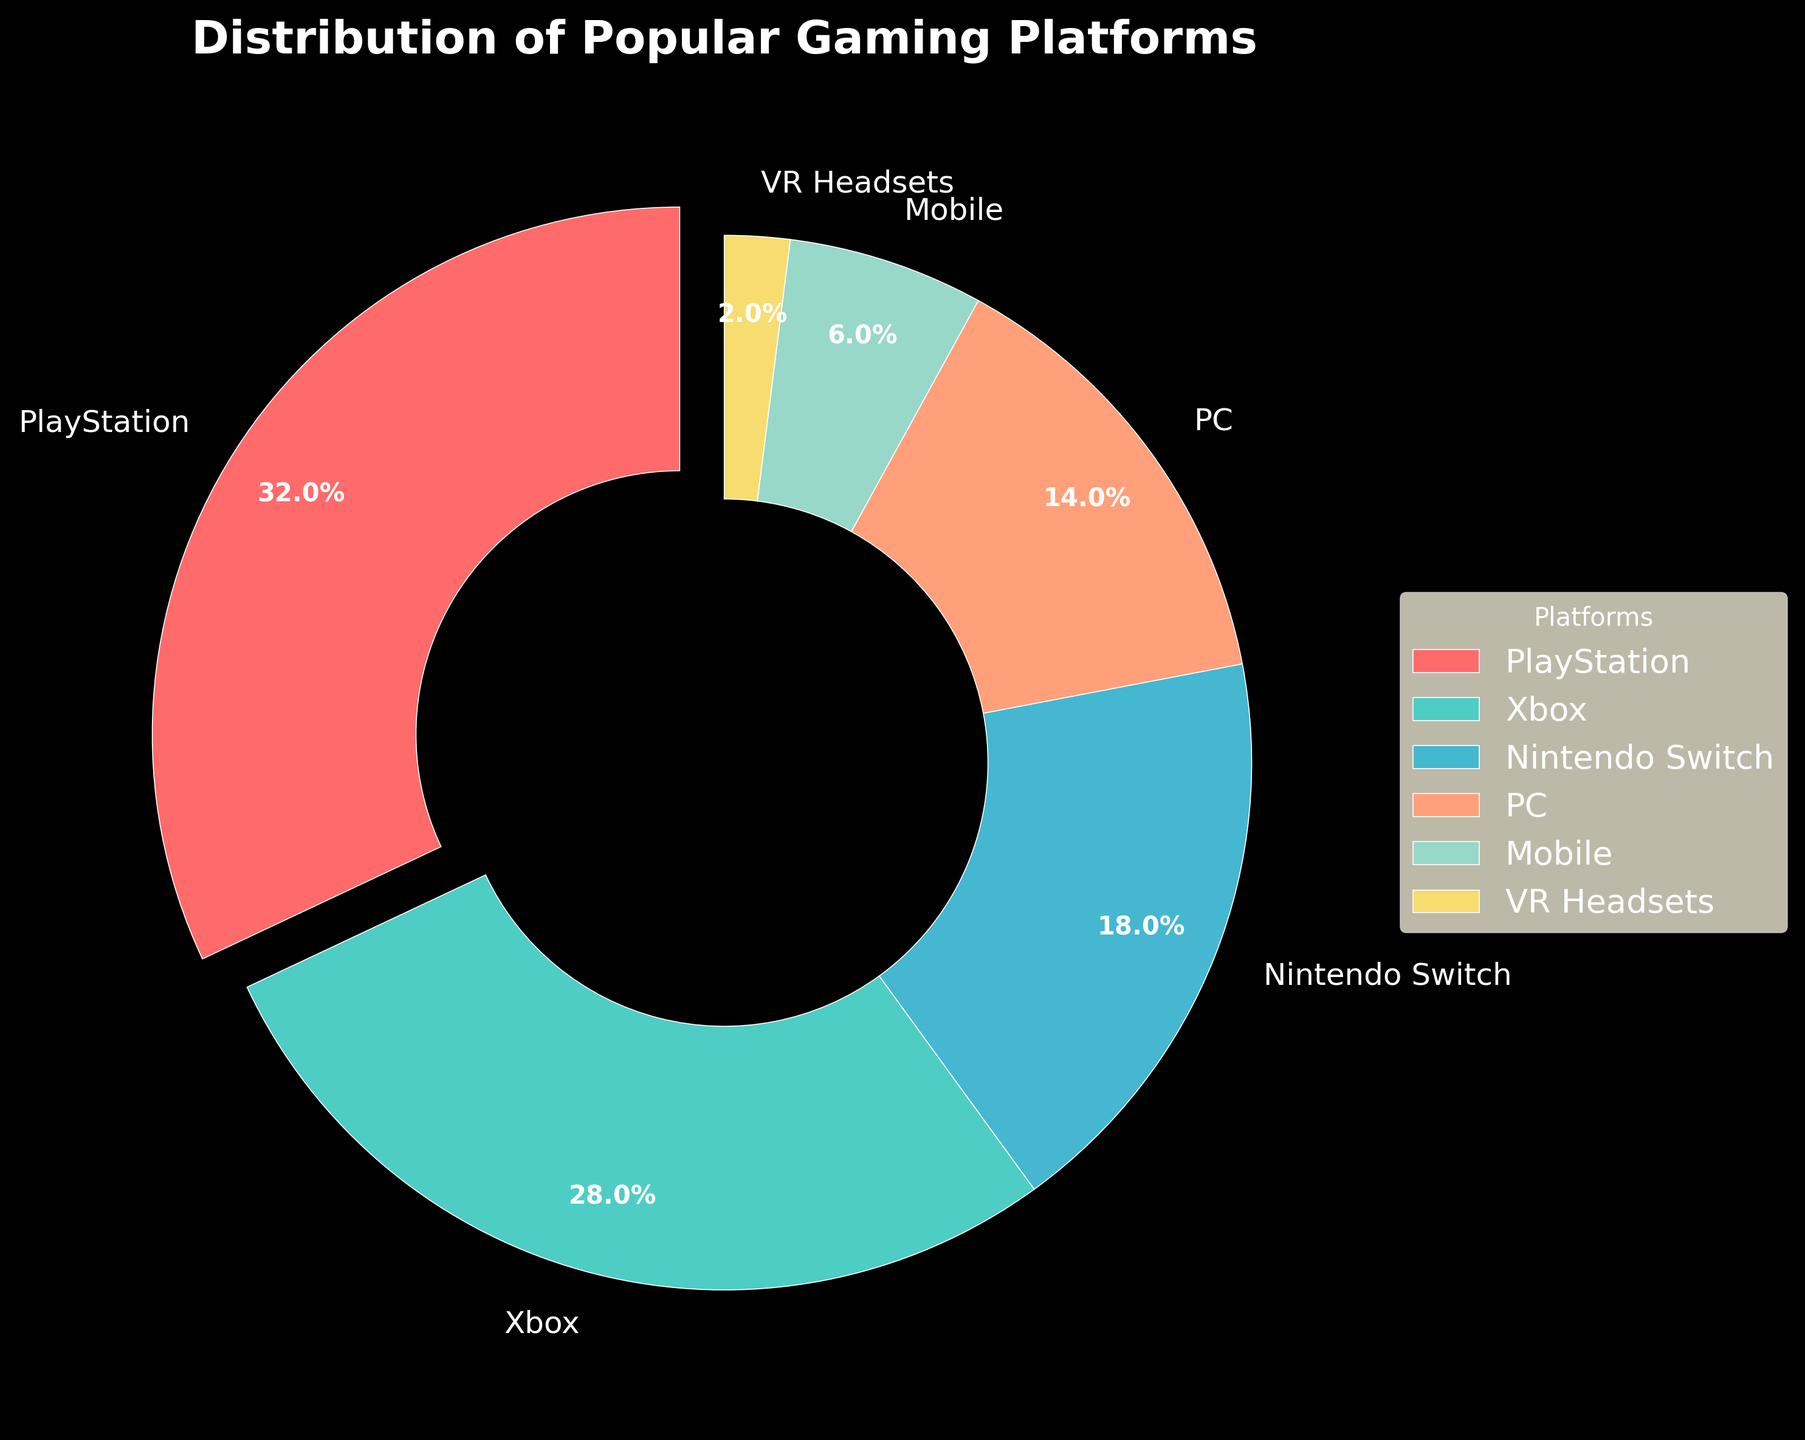Which gaming platform has the highest distribution among local consumers? The gaming platform with the highest distribution can be identified by the largest slice in the pie chart. From the chart, PlayStation has the largest slice with 32%.
Answer: PlayStation Which two platforms have the closest distribution percentages? To find the two platforms with the closest percentages, compare each slice in the pie chart. From the chart, Xbox and Nintendo Switch have distributions of 28% and 18%, respectively, making them the closest pair.
Answer: Xbox and Nintendo Switch What is the combined percentage of users who prefer PC and Mobile platforms? Add the percentages of the PC and Mobile platforms by summing the values from the chart. PC has 14% and Mobile has 6%, so the combined percentage is 14% + 6% = 20%.
Answer: 20% How much more popular is PlayStation compared to VR Headsets? Subtract the percentage of VR Headsets from the percentage of PlayStation. PlayStation has 32% and VR Headsets have 2%, so the difference is 32% - 2% = 30%.
Answer: 30% What color represents the Nintendo Switch on the pie chart? Identify the color associated with the Nintendo Switch slice from the legend adjacent to the pie chart. The Nintendo Switch is represented by the third color, which is light blue.
Answer: Light blue Which platform has the smallest distribution and what is its percentage? The smallest slice in the pie chart corresponds to the platform with the smallest distribution. VR Headsets have the smallest slice with a distribution of 2%.
Answer: VR Headsets, 2% What is the total percentage of users who prefer either PlayStation or Xbox? Add the percentages for PlayStation and Xbox from the chart. PlayStation has 32% and Xbox has 28%, so the total percentage is 32% + 28% = 60%.
Answer: 60% Is the percentage of Mobile platform users greater than 5%? Refer to the pie chart to find the percentage for the Mobile platform and compare it to 5%. The Mobile platform has 6%, which is greater than 5%.
Answer: Yes What percentage of consumers use consoles (PlayStation, Xbox, or Nintendo Switch) versus other platforms? Sum the percentages of PlayStation, Xbox, and Nintendo Switch to find the total for consoles, then compare it to the remaining platforms. PlayStation (32%), Xbox (28%), and Nintendo Switch (18%) add up to 32% + 28% + 18% = 78%. The remaining percentage is 100% - 78% = 22%.
Answer: 78% vs. 22% Which platform is represented by the green color in the pie chart? Identify the slice corresponding to the green color from the legend or the pie chart itself. The green color represents the Xbox platform.
Answer: Xbox 